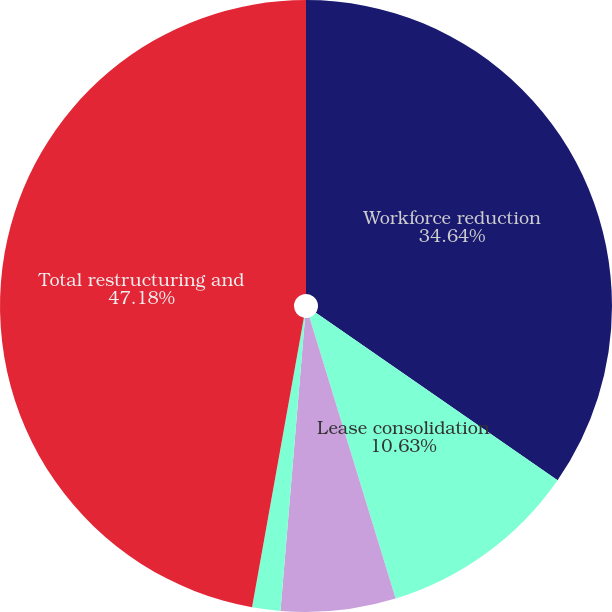<chart> <loc_0><loc_0><loc_500><loc_500><pie_chart><fcel>Workforce reduction<fcel>Lease consolidation<fcel>Asset impairments<fcel>Other related expenses<fcel>Total restructuring and<nl><fcel>34.64%<fcel>10.63%<fcel>6.06%<fcel>1.49%<fcel>47.18%<nl></chart> 